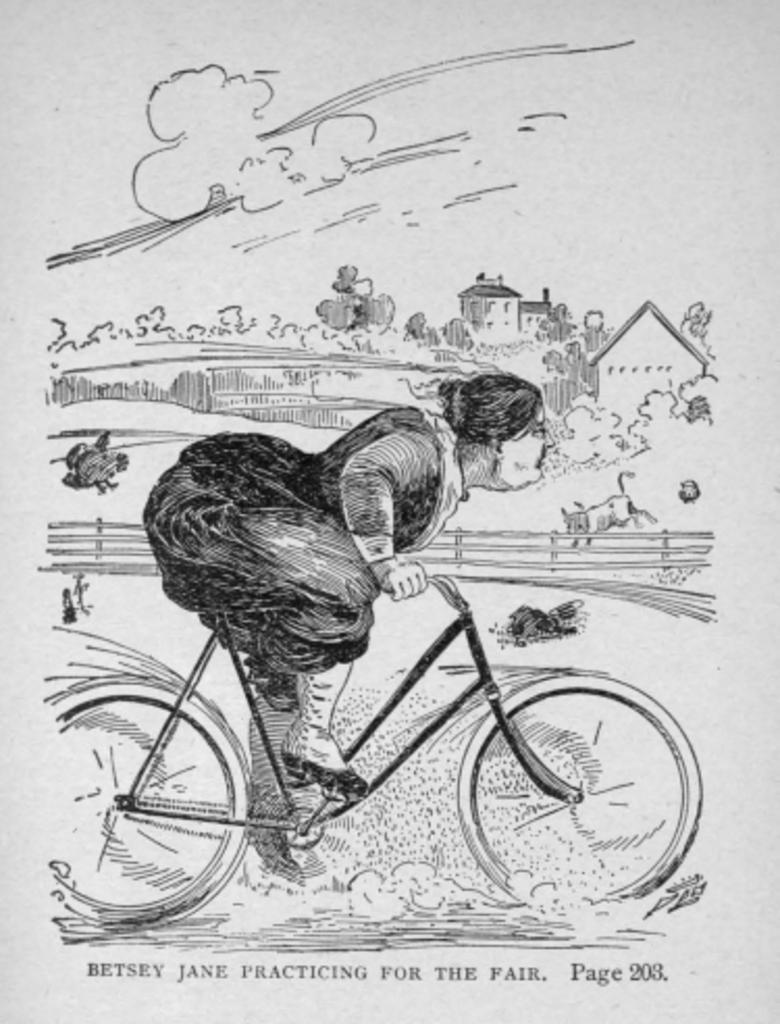Could you give a brief overview of what you see in this image? In this image we can see the sketch of a person who is riding the bicycle towards the right side. In the background there are few houses and trees. At the bottom of this sketch there is some text. This is a black and white image. 